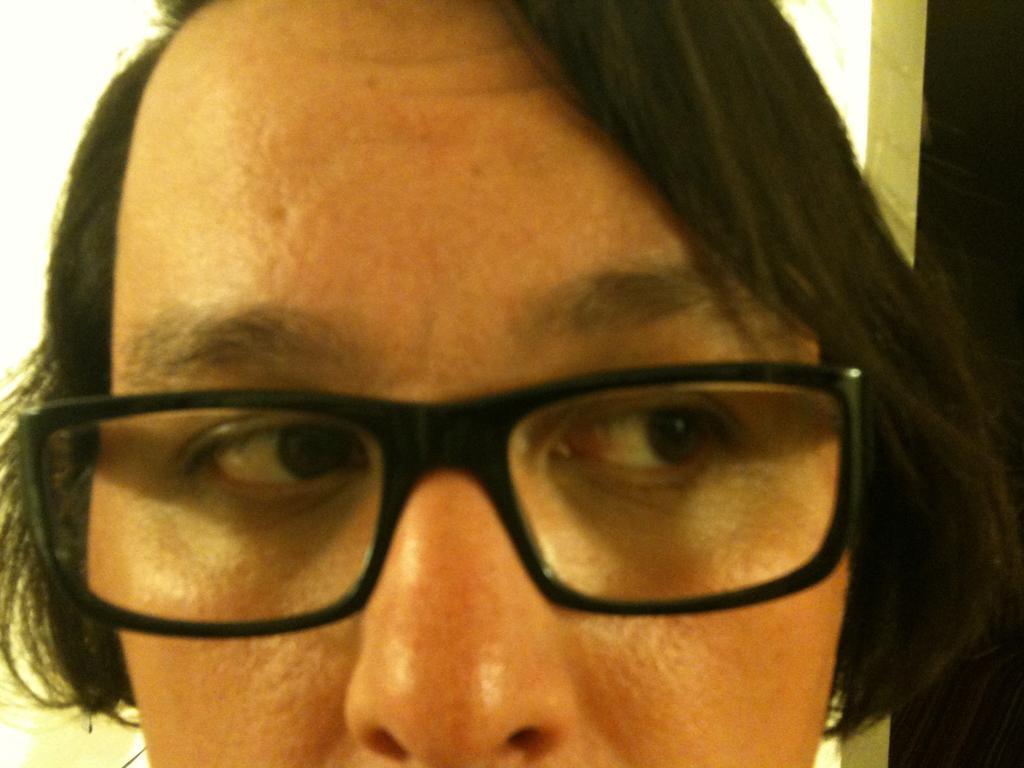Could you give a brief overview of what you see in this image? This image consists of a person wearing a black color specs. In the background, it looks like a door. 